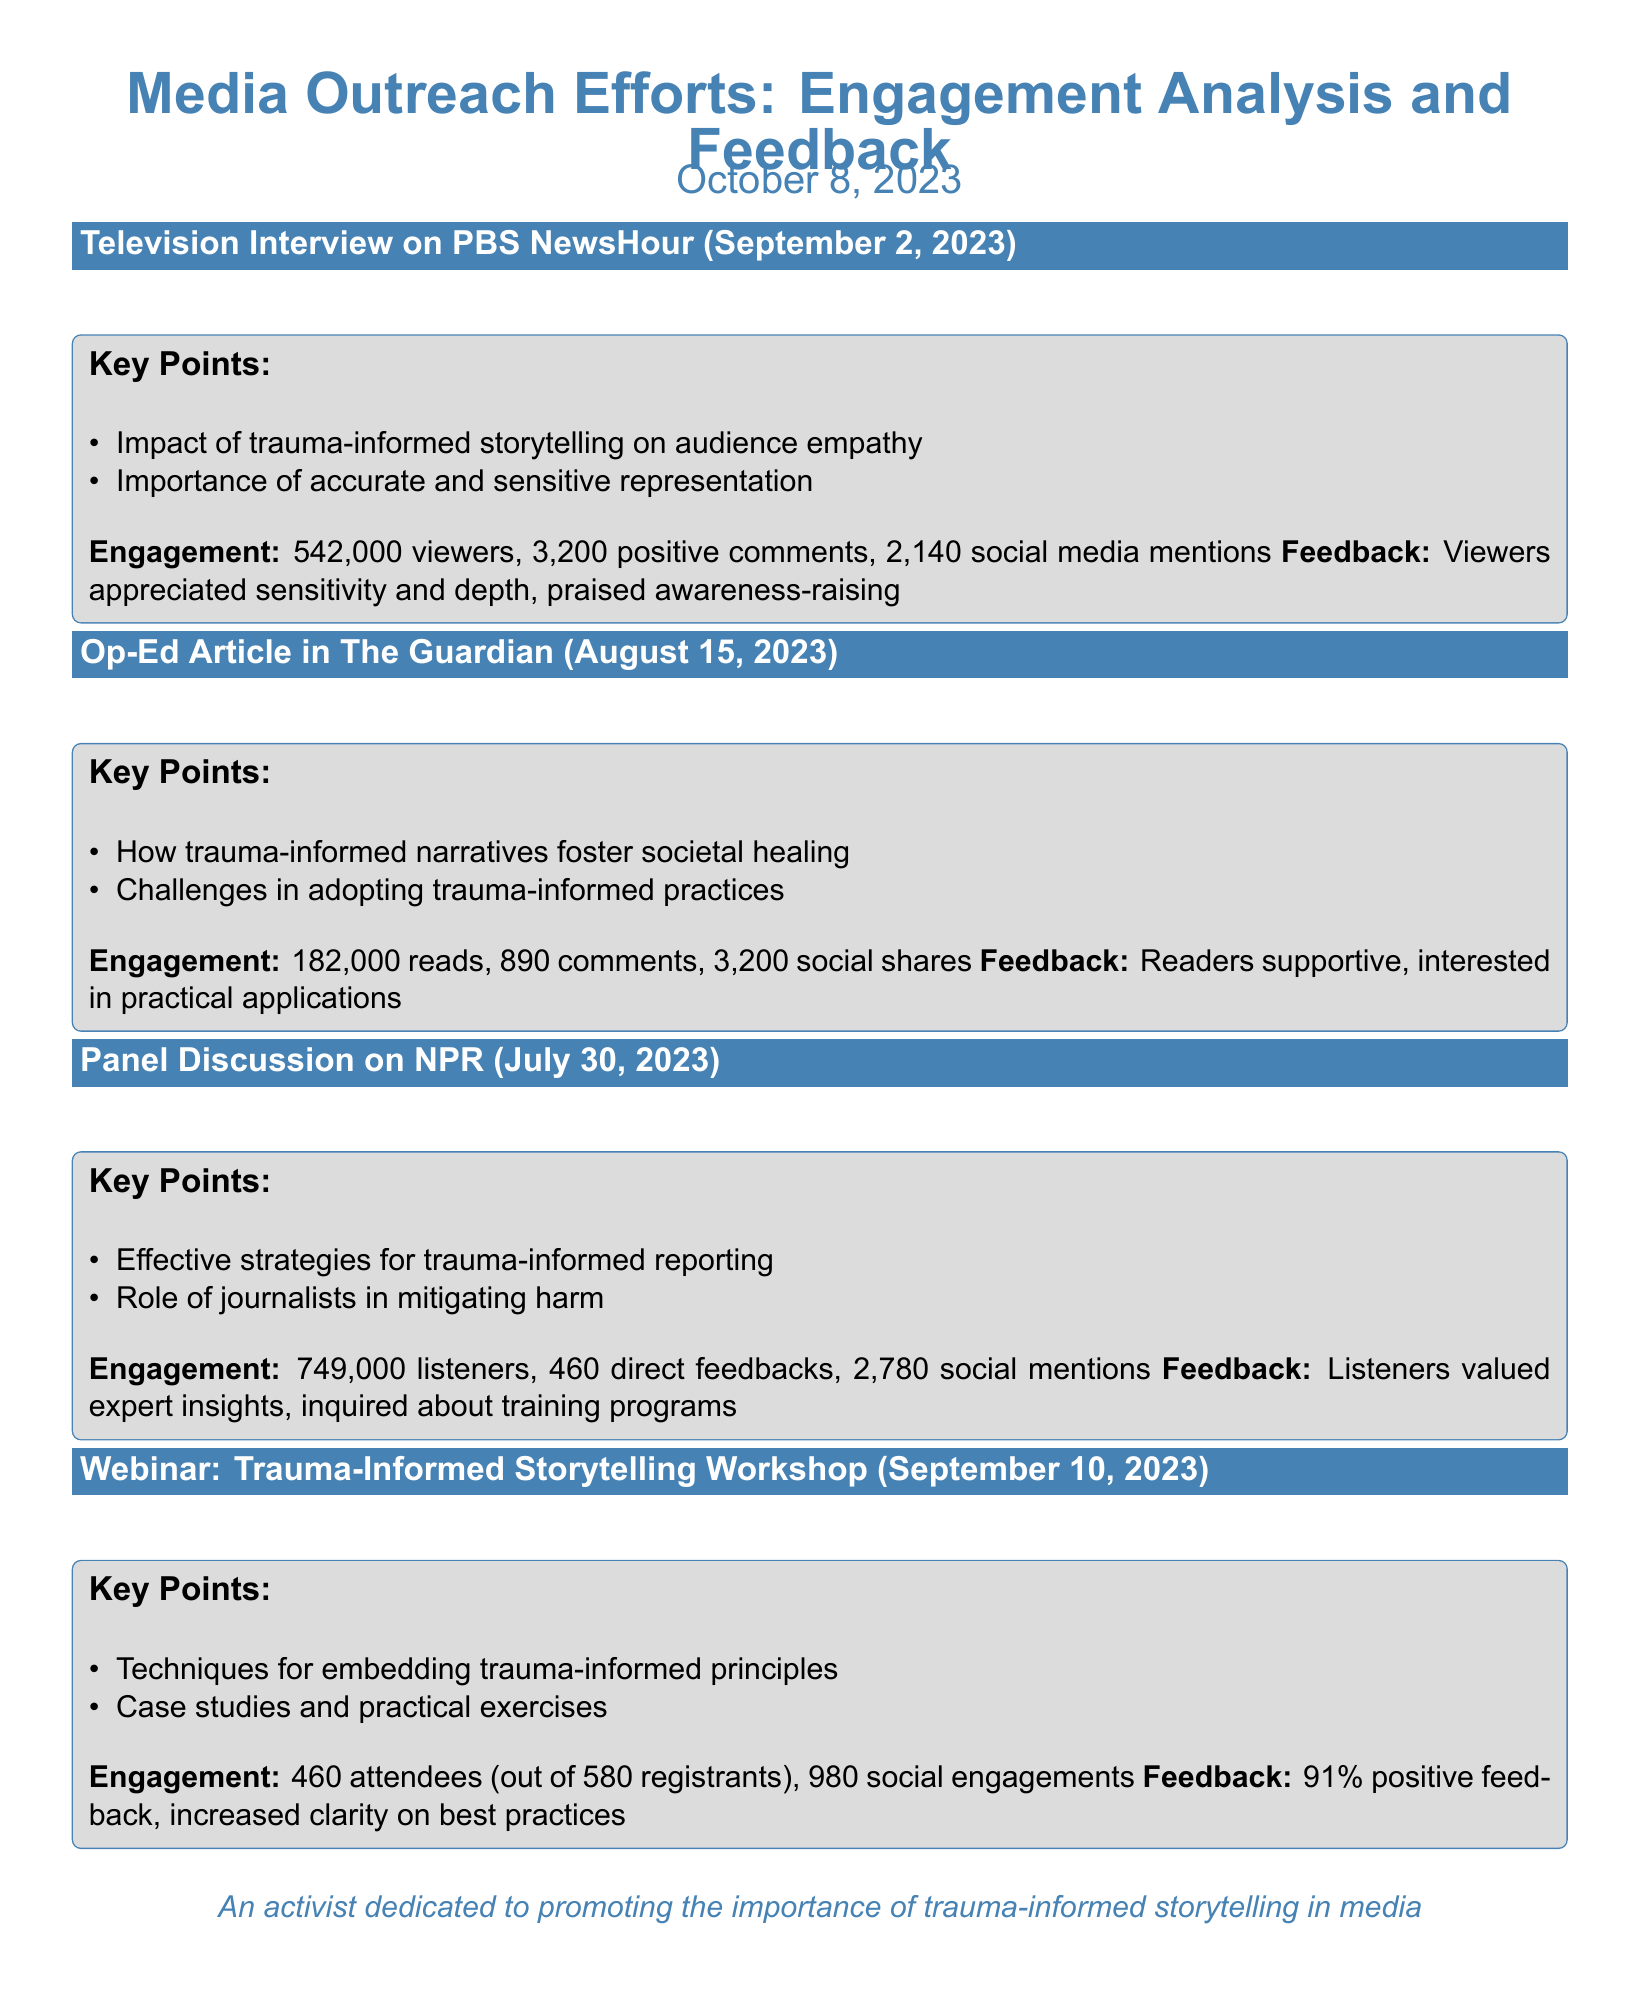What was the total viewer engagement for the PBS NewsHour interview? The total viewer engagement is given as 542,000 viewers.
Answer: 542,000 What date was the op-ed article published in The Guardian? The publication date is explicitly mentioned as August 15, 2023.
Answer: August 15, 2023 How many positive comments were received for the PBS NewsHour interview? The number of positive comments for the interview is stated as 3,200.
Answer: 3,200 Which platform hosted the panel discussion? The panel discussion took place on NPR, as noted in the entry.
Answer: NPR What percentage of positive feedback was received from the webinar participants? The feedback percentage from the webinar participants is explicitly mentioned as 91%.
Answer: 91% What was a key point mentioned during the panel discussion? One of the key points made during the discussion is about effective strategies for trauma-informed reporting.
Answer: Effective strategies for trauma-informed reporting How many social shares did the op-ed article receive? Social shares for the op-ed article are given as 3,200.
Answer: 3,200 What was a common theme in the feedback for both the op-ed article and the webinar? Both received feedback indicating interest in practical applications for trauma-informed storytelling.
Answer: Interest in practical applications What was the total number of attendees for the Trauma-Informed Storytelling Workshop? The total number of attendees is recorded as 460.
Answer: 460 